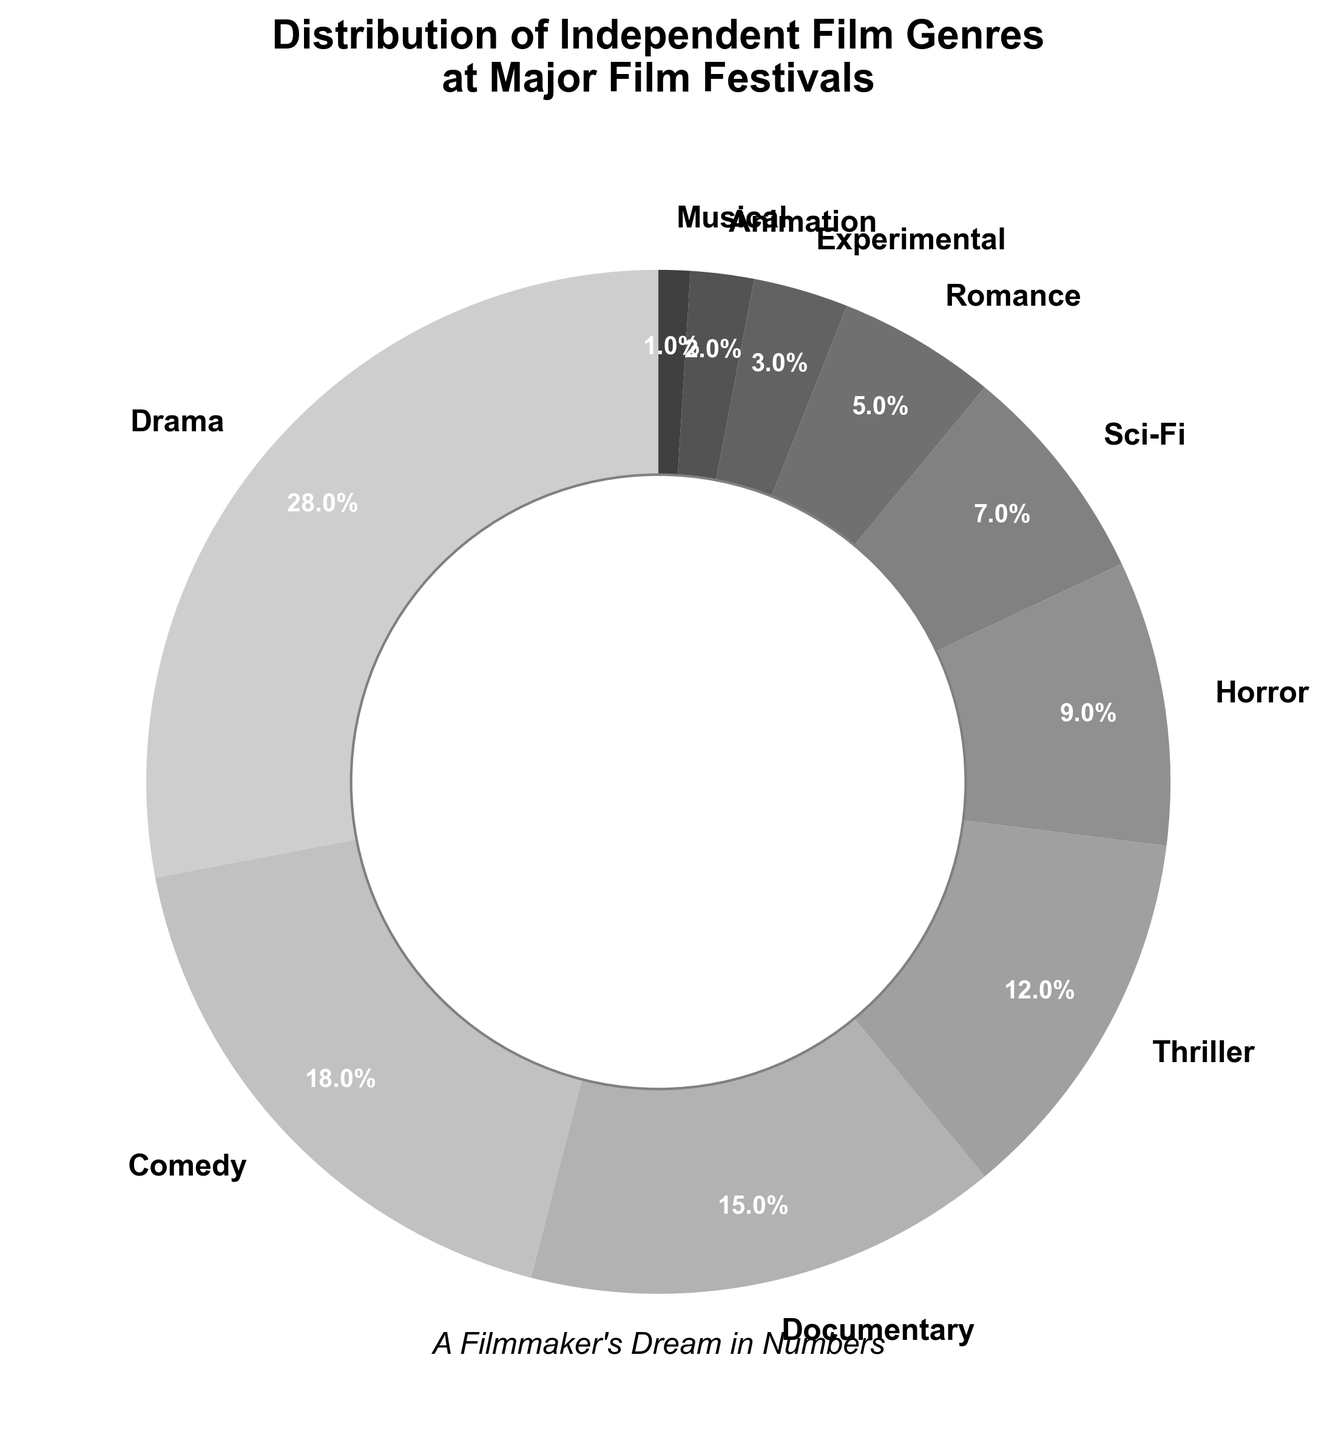What's the genre with the smallest percentage? Looking at the pie chart, the slice with the smallest percentage is the one labeled "Musical" with 1%.
Answer: Musical Which genres have a combined total percentage greater than 30%? Adding the percentages of the top genres, we see Drama (28%) and Comedy (18%) sum up to 46%, which is greater than 30%. Thus, Drama and Comedy have a combined total percentage greater than 30%.
Answer: Drama, Comedy What's the difference in percentage between Drama and Documentary genres? The percentage for Drama is 28% and for Documentary, it's 15%. Subtracting these, the difference is 28% - 15% = 13%.
Answer: 13% Which genre percentages add up to exactly 37%? Checking combinations of percentages, we find Horror (9%) and Thriller (12%) sum up to 21%, adding Comedy (18%) to that gives 39% which is close. By trying different combinations, we find Sci-Fi (7%) plus Documentary (15%) plus Romance (5%) plus Experimental (3%) plus Animation (2%) add up to 32%. Adding 5% from Romance and combining Horror (9%) gives 41%. Thus, exact combinations may not sum exactly.
Answer: None Which two genres have percentages closest to each other? Comparing the percentages, we see that Sci-Fi (7%) and Romance (5%) have a difference of 2%, which is the closest among all pairs.
Answer: Sci-Fi and Romance What's the combined percentage of Animation, Experimental, and Musical genres? Adding the percentages for Animation (2%), Experimental (3%), and Musical (1%) gives 2% + 3% + 1% = 6%.
Answer: 6% Is the percentage of Thriller greater than that of Sci-Fi and Horror combined? Sci-Fi is 7% and Horror is 9%, which together sum up to 16%. Thriller is 12%. Since 12% is less than 16%, Thriller's percentage is not greater.
Answer: No What is the average percentage of the top three genres? The top three genres are Drama (28%), Comedy (18%), and Documentary (15%). Adding these gives 28% + 18% + 15% = 61%. The average is 61% divided by 3, which is 20.33%.
Answer: 20.33% In terms of visual size, which wedge is the largest on the chart? The largest wedge corresponds to Drama, which is the genre with the highest percentage at 28%.
Answer: Drama 